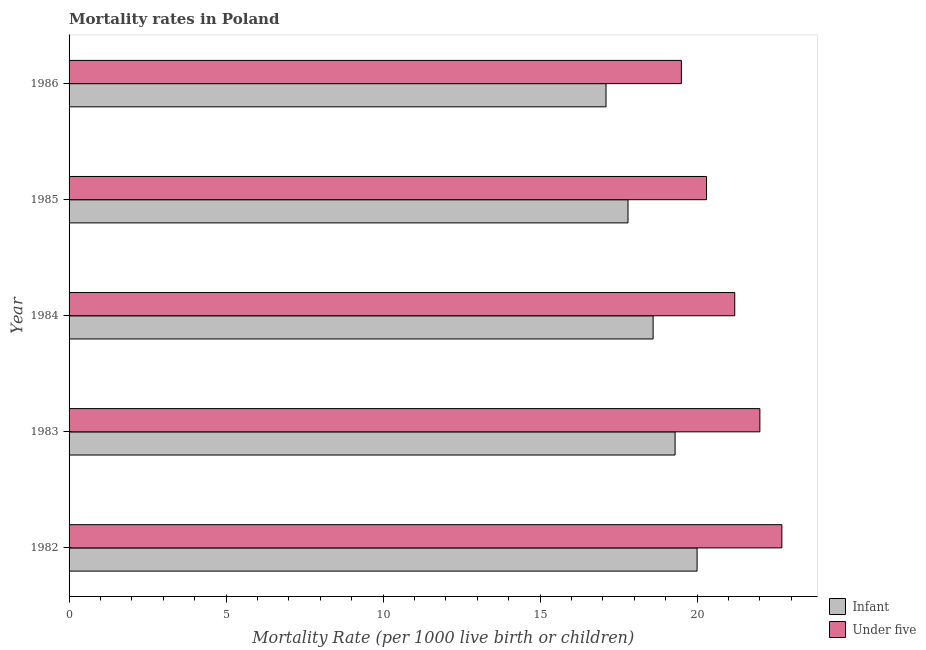How many groups of bars are there?
Your answer should be compact. 5. Are the number of bars per tick equal to the number of legend labels?
Ensure brevity in your answer.  Yes. Are the number of bars on each tick of the Y-axis equal?
Provide a succinct answer. Yes. How many bars are there on the 5th tick from the top?
Make the answer very short. 2. What is the under-5 mortality rate in 1985?
Keep it short and to the point. 20.3. Across all years, what is the maximum infant mortality rate?
Provide a succinct answer. 20. Across all years, what is the minimum infant mortality rate?
Provide a succinct answer. 17.1. In which year was the infant mortality rate maximum?
Your response must be concise. 1982. What is the total under-5 mortality rate in the graph?
Provide a succinct answer. 105.7. What is the difference between the infant mortality rate in 1982 and that in 1983?
Make the answer very short. 0.7. What is the difference between the infant mortality rate in 1984 and the under-5 mortality rate in 1982?
Give a very brief answer. -4.1. What is the average infant mortality rate per year?
Your answer should be very brief. 18.56. In how many years, is the infant mortality rate greater than 16 ?
Your answer should be compact. 5. What is the ratio of the infant mortality rate in 1983 to that in 1985?
Provide a succinct answer. 1.08. Is the infant mortality rate in 1982 less than that in 1983?
Give a very brief answer. No. Is the difference between the infant mortality rate in 1982 and 1985 greater than the difference between the under-5 mortality rate in 1982 and 1985?
Provide a short and direct response. No. What is the difference between the highest and the second highest under-5 mortality rate?
Keep it short and to the point. 0.7. What is the difference between the highest and the lowest infant mortality rate?
Offer a very short reply. 2.9. In how many years, is the under-5 mortality rate greater than the average under-5 mortality rate taken over all years?
Provide a short and direct response. 3. What does the 2nd bar from the top in 1983 represents?
Your response must be concise. Infant. What does the 1st bar from the bottom in 1983 represents?
Provide a short and direct response. Infant. Are all the bars in the graph horizontal?
Offer a very short reply. Yes. What is the difference between two consecutive major ticks on the X-axis?
Your answer should be very brief. 5. Are the values on the major ticks of X-axis written in scientific E-notation?
Provide a succinct answer. No. Does the graph contain grids?
Give a very brief answer. No. Where does the legend appear in the graph?
Give a very brief answer. Bottom right. What is the title of the graph?
Make the answer very short. Mortality rates in Poland. Does "Short-term debt" appear as one of the legend labels in the graph?
Keep it short and to the point. No. What is the label or title of the X-axis?
Make the answer very short. Mortality Rate (per 1000 live birth or children). What is the label or title of the Y-axis?
Your answer should be very brief. Year. What is the Mortality Rate (per 1000 live birth or children) in Infant in 1982?
Offer a terse response. 20. What is the Mortality Rate (per 1000 live birth or children) of Under five in 1982?
Ensure brevity in your answer.  22.7. What is the Mortality Rate (per 1000 live birth or children) in Infant in 1983?
Offer a terse response. 19.3. What is the Mortality Rate (per 1000 live birth or children) in Under five in 1984?
Provide a succinct answer. 21.2. What is the Mortality Rate (per 1000 live birth or children) of Under five in 1985?
Your answer should be very brief. 20.3. Across all years, what is the maximum Mortality Rate (per 1000 live birth or children) in Under five?
Offer a terse response. 22.7. Across all years, what is the minimum Mortality Rate (per 1000 live birth or children) of Infant?
Your response must be concise. 17.1. What is the total Mortality Rate (per 1000 live birth or children) in Infant in the graph?
Provide a succinct answer. 92.8. What is the total Mortality Rate (per 1000 live birth or children) in Under five in the graph?
Provide a succinct answer. 105.7. What is the difference between the Mortality Rate (per 1000 live birth or children) in Infant in 1982 and that in 1983?
Make the answer very short. 0.7. What is the difference between the Mortality Rate (per 1000 live birth or children) in Infant in 1982 and that in 1985?
Offer a terse response. 2.2. What is the difference between the Mortality Rate (per 1000 live birth or children) of Under five in 1982 and that in 1985?
Offer a terse response. 2.4. What is the difference between the Mortality Rate (per 1000 live birth or children) in Infant in 1982 and that in 1986?
Provide a succinct answer. 2.9. What is the difference between the Mortality Rate (per 1000 live birth or children) of Infant in 1983 and that in 1984?
Make the answer very short. 0.7. What is the difference between the Mortality Rate (per 1000 live birth or children) of Infant in 1983 and that in 1985?
Your answer should be compact. 1.5. What is the difference between the Mortality Rate (per 1000 live birth or children) of Infant in 1983 and that in 1986?
Ensure brevity in your answer.  2.2. What is the difference between the Mortality Rate (per 1000 live birth or children) in Under five in 1984 and that in 1985?
Offer a very short reply. 0.9. What is the difference between the Mortality Rate (per 1000 live birth or children) in Under five in 1984 and that in 1986?
Keep it short and to the point. 1.7. What is the difference between the Mortality Rate (per 1000 live birth or children) in Infant in 1985 and that in 1986?
Offer a very short reply. 0.7. What is the difference between the Mortality Rate (per 1000 live birth or children) in Under five in 1985 and that in 1986?
Offer a terse response. 0.8. What is the difference between the Mortality Rate (per 1000 live birth or children) of Infant in 1982 and the Mortality Rate (per 1000 live birth or children) of Under five in 1984?
Your answer should be very brief. -1.2. What is the difference between the Mortality Rate (per 1000 live birth or children) in Infant in 1982 and the Mortality Rate (per 1000 live birth or children) in Under five in 1986?
Keep it short and to the point. 0.5. What is the difference between the Mortality Rate (per 1000 live birth or children) of Infant in 1983 and the Mortality Rate (per 1000 live birth or children) of Under five in 1984?
Your answer should be very brief. -1.9. What is the difference between the Mortality Rate (per 1000 live birth or children) in Infant in 1984 and the Mortality Rate (per 1000 live birth or children) in Under five in 1985?
Provide a short and direct response. -1.7. What is the difference between the Mortality Rate (per 1000 live birth or children) of Infant in 1984 and the Mortality Rate (per 1000 live birth or children) of Under five in 1986?
Your response must be concise. -0.9. What is the average Mortality Rate (per 1000 live birth or children) of Infant per year?
Keep it short and to the point. 18.56. What is the average Mortality Rate (per 1000 live birth or children) in Under five per year?
Your response must be concise. 21.14. In the year 1985, what is the difference between the Mortality Rate (per 1000 live birth or children) of Infant and Mortality Rate (per 1000 live birth or children) of Under five?
Your answer should be compact. -2.5. In the year 1986, what is the difference between the Mortality Rate (per 1000 live birth or children) of Infant and Mortality Rate (per 1000 live birth or children) of Under five?
Keep it short and to the point. -2.4. What is the ratio of the Mortality Rate (per 1000 live birth or children) of Infant in 1982 to that in 1983?
Provide a succinct answer. 1.04. What is the ratio of the Mortality Rate (per 1000 live birth or children) in Under five in 1982 to that in 1983?
Provide a short and direct response. 1.03. What is the ratio of the Mortality Rate (per 1000 live birth or children) in Infant in 1982 to that in 1984?
Provide a succinct answer. 1.08. What is the ratio of the Mortality Rate (per 1000 live birth or children) of Under five in 1982 to that in 1984?
Make the answer very short. 1.07. What is the ratio of the Mortality Rate (per 1000 live birth or children) in Infant in 1982 to that in 1985?
Make the answer very short. 1.12. What is the ratio of the Mortality Rate (per 1000 live birth or children) of Under five in 1982 to that in 1985?
Your answer should be very brief. 1.12. What is the ratio of the Mortality Rate (per 1000 live birth or children) of Infant in 1982 to that in 1986?
Make the answer very short. 1.17. What is the ratio of the Mortality Rate (per 1000 live birth or children) in Under five in 1982 to that in 1986?
Give a very brief answer. 1.16. What is the ratio of the Mortality Rate (per 1000 live birth or children) in Infant in 1983 to that in 1984?
Provide a succinct answer. 1.04. What is the ratio of the Mortality Rate (per 1000 live birth or children) in Under five in 1983 to that in 1984?
Provide a succinct answer. 1.04. What is the ratio of the Mortality Rate (per 1000 live birth or children) of Infant in 1983 to that in 1985?
Your answer should be very brief. 1.08. What is the ratio of the Mortality Rate (per 1000 live birth or children) in Under five in 1983 to that in 1985?
Give a very brief answer. 1.08. What is the ratio of the Mortality Rate (per 1000 live birth or children) of Infant in 1983 to that in 1986?
Ensure brevity in your answer.  1.13. What is the ratio of the Mortality Rate (per 1000 live birth or children) in Under five in 1983 to that in 1986?
Ensure brevity in your answer.  1.13. What is the ratio of the Mortality Rate (per 1000 live birth or children) of Infant in 1984 to that in 1985?
Your answer should be very brief. 1.04. What is the ratio of the Mortality Rate (per 1000 live birth or children) of Under five in 1984 to that in 1985?
Ensure brevity in your answer.  1.04. What is the ratio of the Mortality Rate (per 1000 live birth or children) in Infant in 1984 to that in 1986?
Ensure brevity in your answer.  1.09. What is the ratio of the Mortality Rate (per 1000 live birth or children) in Under five in 1984 to that in 1986?
Make the answer very short. 1.09. What is the ratio of the Mortality Rate (per 1000 live birth or children) in Infant in 1985 to that in 1986?
Your answer should be compact. 1.04. What is the ratio of the Mortality Rate (per 1000 live birth or children) in Under five in 1985 to that in 1986?
Offer a very short reply. 1.04. What is the difference between the highest and the lowest Mortality Rate (per 1000 live birth or children) of Infant?
Provide a short and direct response. 2.9. What is the difference between the highest and the lowest Mortality Rate (per 1000 live birth or children) in Under five?
Your answer should be very brief. 3.2. 